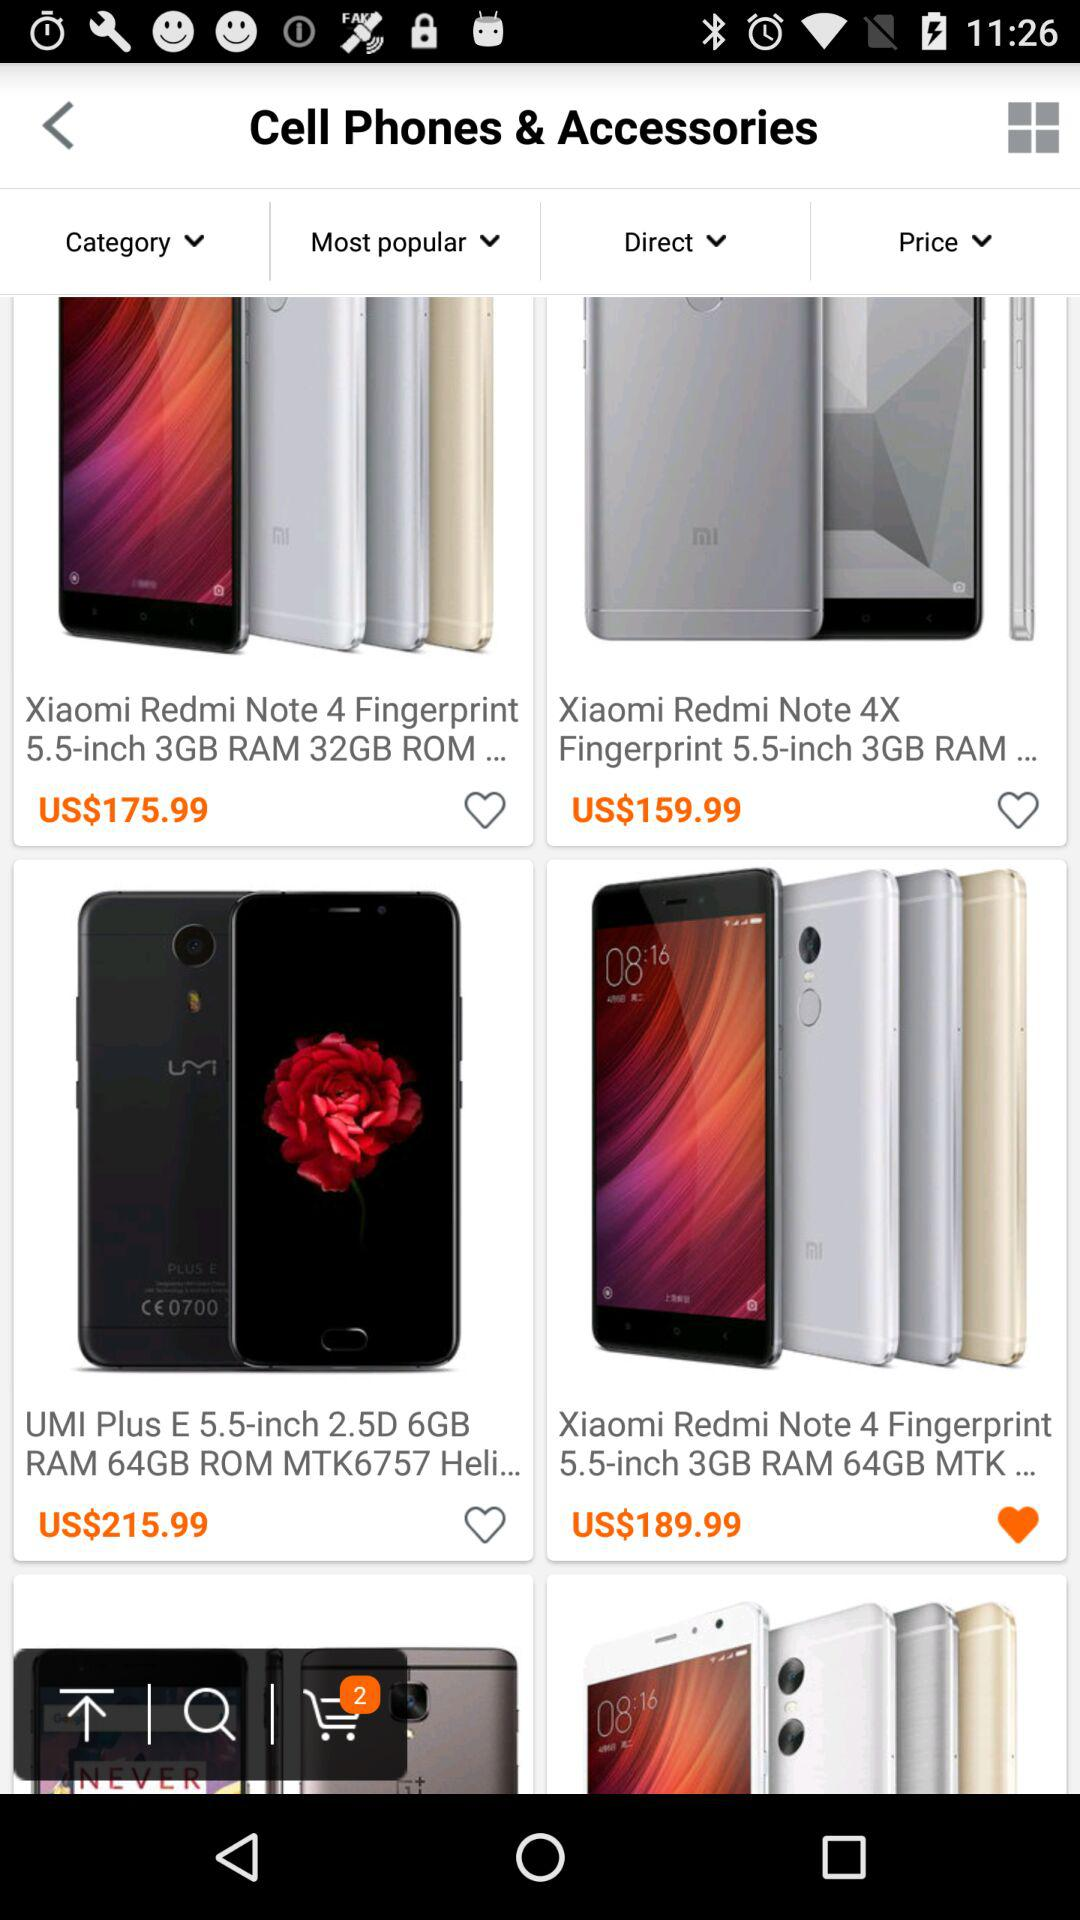How much does the "Xiaomi Redmi Note 4 Fingerprint 5.5-inch 3GB RAM 32GB ROM..." cost? The "Xiaomi Redmi Note 4 Fingerprint 5.5-inch 3GB RAM 32GB ROM..." costs US$175.99. 